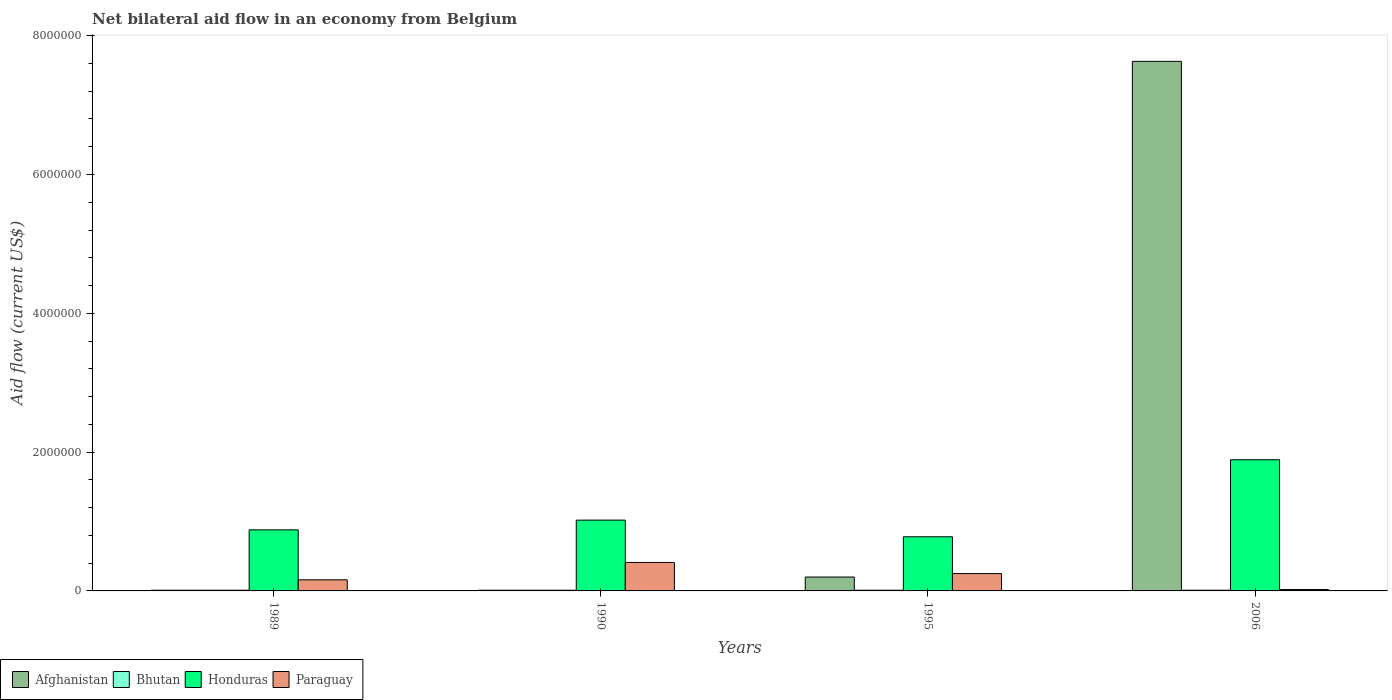How many groups of bars are there?
Provide a short and direct response. 4. Are the number of bars on each tick of the X-axis equal?
Provide a short and direct response. Yes. How many bars are there on the 1st tick from the right?
Provide a succinct answer. 4. What is the label of the 1st group of bars from the left?
Offer a very short reply. 1989. In how many cases, is the number of bars for a given year not equal to the number of legend labels?
Your answer should be compact. 0. What is the net bilateral aid flow in Honduras in 2006?
Keep it short and to the point. 1.89e+06. Across all years, what is the maximum net bilateral aid flow in Afghanistan?
Offer a very short reply. 7.63e+06. Across all years, what is the minimum net bilateral aid flow in Paraguay?
Provide a succinct answer. 2.00e+04. In which year was the net bilateral aid flow in Afghanistan maximum?
Offer a very short reply. 2006. In which year was the net bilateral aid flow in Honduras minimum?
Provide a succinct answer. 1995. What is the total net bilateral aid flow in Bhutan in the graph?
Make the answer very short. 4.00e+04. In the year 1995, what is the difference between the net bilateral aid flow in Paraguay and net bilateral aid flow in Afghanistan?
Provide a short and direct response. 5.00e+04. In how many years, is the net bilateral aid flow in Paraguay greater than 4400000 US$?
Ensure brevity in your answer.  0. What is the ratio of the net bilateral aid flow in Honduras in 1995 to that in 2006?
Your response must be concise. 0.41. Is the difference between the net bilateral aid flow in Paraguay in 1989 and 2006 greater than the difference between the net bilateral aid flow in Afghanistan in 1989 and 2006?
Provide a succinct answer. Yes. What is the difference between the highest and the second highest net bilateral aid flow in Afghanistan?
Your response must be concise. 7.43e+06. Is it the case that in every year, the sum of the net bilateral aid flow in Paraguay and net bilateral aid flow in Afghanistan is greater than the sum of net bilateral aid flow in Honduras and net bilateral aid flow in Bhutan?
Your answer should be very brief. No. What does the 4th bar from the left in 2006 represents?
Your answer should be compact. Paraguay. What does the 3rd bar from the right in 1995 represents?
Offer a very short reply. Bhutan. Is it the case that in every year, the sum of the net bilateral aid flow in Bhutan and net bilateral aid flow in Paraguay is greater than the net bilateral aid flow in Honduras?
Your answer should be compact. No. How many bars are there?
Keep it short and to the point. 16. Are all the bars in the graph horizontal?
Your answer should be very brief. No. How many years are there in the graph?
Make the answer very short. 4. Does the graph contain any zero values?
Provide a succinct answer. No. Where does the legend appear in the graph?
Ensure brevity in your answer.  Bottom left. How are the legend labels stacked?
Ensure brevity in your answer.  Horizontal. What is the title of the graph?
Keep it short and to the point. Net bilateral aid flow in an economy from Belgium. What is the label or title of the Y-axis?
Provide a short and direct response. Aid flow (current US$). What is the Aid flow (current US$) of Afghanistan in 1989?
Keep it short and to the point. 10000. What is the Aid flow (current US$) in Bhutan in 1989?
Offer a terse response. 10000. What is the Aid flow (current US$) of Honduras in 1989?
Offer a very short reply. 8.80e+05. What is the Aid flow (current US$) of Paraguay in 1989?
Offer a very short reply. 1.60e+05. What is the Aid flow (current US$) of Afghanistan in 1990?
Give a very brief answer. 10000. What is the Aid flow (current US$) of Honduras in 1990?
Provide a succinct answer. 1.02e+06. What is the Aid flow (current US$) of Afghanistan in 1995?
Give a very brief answer. 2.00e+05. What is the Aid flow (current US$) in Bhutan in 1995?
Your response must be concise. 10000. What is the Aid flow (current US$) in Honduras in 1995?
Your answer should be very brief. 7.80e+05. What is the Aid flow (current US$) in Paraguay in 1995?
Offer a terse response. 2.50e+05. What is the Aid flow (current US$) of Afghanistan in 2006?
Your answer should be very brief. 7.63e+06. What is the Aid flow (current US$) of Bhutan in 2006?
Your response must be concise. 10000. What is the Aid flow (current US$) of Honduras in 2006?
Offer a terse response. 1.89e+06. What is the Aid flow (current US$) in Paraguay in 2006?
Your response must be concise. 2.00e+04. Across all years, what is the maximum Aid flow (current US$) in Afghanistan?
Provide a short and direct response. 7.63e+06. Across all years, what is the maximum Aid flow (current US$) of Bhutan?
Give a very brief answer. 10000. Across all years, what is the maximum Aid flow (current US$) of Honduras?
Make the answer very short. 1.89e+06. Across all years, what is the maximum Aid flow (current US$) in Paraguay?
Keep it short and to the point. 4.10e+05. Across all years, what is the minimum Aid flow (current US$) in Honduras?
Give a very brief answer. 7.80e+05. Across all years, what is the minimum Aid flow (current US$) in Paraguay?
Provide a short and direct response. 2.00e+04. What is the total Aid flow (current US$) of Afghanistan in the graph?
Make the answer very short. 7.85e+06. What is the total Aid flow (current US$) in Honduras in the graph?
Offer a terse response. 4.57e+06. What is the total Aid flow (current US$) in Paraguay in the graph?
Your response must be concise. 8.40e+05. What is the difference between the Aid flow (current US$) in Afghanistan in 1989 and that in 1990?
Provide a short and direct response. 0. What is the difference between the Aid flow (current US$) in Bhutan in 1989 and that in 1990?
Provide a succinct answer. 0. What is the difference between the Aid flow (current US$) of Paraguay in 1989 and that in 1990?
Ensure brevity in your answer.  -2.50e+05. What is the difference between the Aid flow (current US$) in Afghanistan in 1989 and that in 1995?
Your answer should be very brief. -1.90e+05. What is the difference between the Aid flow (current US$) in Bhutan in 1989 and that in 1995?
Make the answer very short. 0. What is the difference between the Aid flow (current US$) in Honduras in 1989 and that in 1995?
Your answer should be very brief. 1.00e+05. What is the difference between the Aid flow (current US$) of Paraguay in 1989 and that in 1995?
Give a very brief answer. -9.00e+04. What is the difference between the Aid flow (current US$) of Afghanistan in 1989 and that in 2006?
Provide a short and direct response. -7.62e+06. What is the difference between the Aid flow (current US$) in Bhutan in 1989 and that in 2006?
Your response must be concise. 0. What is the difference between the Aid flow (current US$) in Honduras in 1989 and that in 2006?
Your answer should be compact. -1.01e+06. What is the difference between the Aid flow (current US$) of Afghanistan in 1990 and that in 1995?
Make the answer very short. -1.90e+05. What is the difference between the Aid flow (current US$) in Honduras in 1990 and that in 1995?
Provide a succinct answer. 2.40e+05. What is the difference between the Aid flow (current US$) in Paraguay in 1990 and that in 1995?
Give a very brief answer. 1.60e+05. What is the difference between the Aid flow (current US$) in Afghanistan in 1990 and that in 2006?
Your answer should be compact. -7.62e+06. What is the difference between the Aid flow (current US$) of Bhutan in 1990 and that in 2006?
Your answer should be compact. 0. What is the difference between the Aid flow (current US$) of Honduras in 1990 and that in 2006?
Keep it short and to the point. -8.70e+05. What is the difference between the Aid flow (current US$) in Afghanistan in 1995 and that in 2006?
Provide a short and direct response. -7.43e+06. What is the difference between the Aid flow (current US$) of Bhutan in 1995 and that in 2006?
Your response must be concise. 0. What is the difference between the Aid flow (current US$) in Honduras in 1995 and that in 2006?
Your response must be concise. -1.11e+06. What is the difference between the Aid flow (current US$) in Paraguay in 1995 and that in 2006?
Your answer should be very brief. 2.30e+05. What is the difference between the Aid flow (current US$) of Afghanistan in 1989 and the Aid flow (current US$) of Bhutan in 1990?
Ensure brevity in your answer.  0. What is the difference between the Aid flow (current US$) of Afghanistan in 1989 and the Aid flow (current US$) of Honduras in 1990?
Ensure brevity in your answer.  -1.01e+06. What is the difference between the Aid flow (current US$) of Afghanistan in 1989 and the Aid flow (current US$) of Paraguay in 1990?
Offer a terse response. -4.00e+05. What is the difference between the Aid flow (current US$) of Bhutan in 1989 and the Aid flow (current US$) of Honduras in 1990?
Keep it short and to the point. -1.01e+06. What is the difference between the Aid flow (current US$) in Bhutan in 1989 and the Aid flow (current US$) in Paraguay in 1990?
Your response must be concise. -4.00e+05. What is the difference between the Aid flow (current US$) of Afghanistan in 1989 and the Aid flow (current US$) of Honduras in 1995?
Keep it short and to the point. -7.70e+05. What is the difference between the Aid flow (current US$) of Afghanistan in 1989 and the Aid flow (current US$) of Paraguay in 1995?
Provide a short and direct response. -2.40e+05. What is the difference between the Aid flow (current US$) of Bhutan in 1989 and the Aid flow (current US$) of Honduras in 1995?
Provide a short and direct response. -7.70e+05. What is the difference between the Aid flow (current US$) in Bhutan in 1989 and the Aid flow (current US$) in Paraguay in 1995?
Your answer should be very brief. -2.40e+05. What is the difference between the Aid flow (current US$) in Honduras in 1989 and the Aid flow (current US$) in Paraguay in 1995?
Provide a succinct answer. 6.30e+05. What is the difference between the Aid flow (current US$) of Afghanistan in 1989 and the Aid flow (current US$) of Honduras in 2006?
Make the answer very short. -1.88e+06. What is the difference between the Aid flow (current US$) in Bhutan in 1989 and the Aid flow (current US$) in Honduras in 2006?
Give a very brief answer. -1.88e+06. What is the difference between the Aid flow (current US$) of Bhutan in 1989 and the Aid flow (current US$) of Paraguay in 2006?
Provide a short and direct response. -10000. What is the difference between the Aid flow (current US$) of Honduras in 1989 and the Aid flow (current US$) of Paraguay in 2006?
Keep it short and to the point. 8.60e+05. What is the difference between the Aid flow (current US$) of Afghanistan in 1990 and the Aid flow (current US$) of Bhutan in 1995?
Your answer should be compact. 0. What is the difference between the Aid flow (current US$) of Afghanistan in 1990 and the Aid flow (current US$) of Honduras in 1995?
Keep it short and to the point. -7.70e+05. What is the difference between the Aid flow (current US$) in Bhutan in 1990 and the Aid flow (current US$) in Honduras in 1995?
Make the answer very short. -7.70e+05. What is the difference between the Aid flow (current US$) in Honduras in 1990 and the Aid flow (current US$) in Paraguay in 1995?
Your response must be concise. 7.70e+05. What is the difference between the Aid flow (current US$) in Afghanistan in 1990 and the Aid flow (current US$) in Bhutan in 2006?
Ensure brevity in your answer.  0. What is the difference between the Aid flow (current US$) in Afghanistan in 1990 and the Aid flow (current US$) in Honduras in 2006?
Give a very brief answer. -1.88e+06. What is the difference between the Aid flow (current US$) of Afghanistan in 1990 and the Aid flow (current US$) of Paraguay in 2006?
Ensure brevity in your answer.  -10000. What is the difference between the Aid flow (current US$) in Bhutan in 1990 and the Aid flow (current US$) in Honduras in 2006?
Provide a succinct answer. -1.88e+06. What is the difference between the Aid flow (current US$) of Afghanistan in 1995 and the Aid flow (current US$) of Honduras in 2006?
Your answer should be very brief. -1.69e+06. What is the difference between the Aid flow (current US$) of Afghanistan in 1995 and the Aid flow (current US$) of Paraguay in 2006?
Make the answer very short. 1.80e+05. What is the difference between the Aid flow (current US$) in Bhutan in 1995 and the Aid flow (current US$) in Honduras in 2006?
Your answer should be very brief. -1.88e+06. What is the difference between the Aid flow (current US$) of Honduras in 1995 and the Aid flow (current US$) of Paraguay in 2006?
Keep it short and to the point. 7.60e+05. What is the average Aid flow (current US$) in Afghanistan per year?
Make the answer very short. 1.96e+06. What is the average Aid flow (current US$) in Honduras per year?
Your answer should be very brief. 1.14e+06. In the year 1989, what is the difference between the Aid flow (current US$) of Afghanistan and Aid flow (current US$) of Bhutan?
Offer a terse response. 0. In the year 1989, what is the difference between the Aid flow (current US$) of Afghanistan and Aid flow (current US$) of Honduras?
Offer a terse response. -8.70e+05. In the year 1989, what is the difference between the Aid flow (current US$) of Bhutan and Aid flow (current US$) of Honduras?
Provide a short and direct response. -8.70e+05. In the year 1989, what is the difference between the Aid flow (current US$) of Bhutan and Aid flow (current US$) of Paraguay?
Offer a very short reply. -1.50e+05. In the year 1989, what is the difference between the Aid flow (current US$) in Honduras and Aid flow (current US$) in Paraguay?
Offer a very short reply. 7.20e+05. In the year 1990, what is the difference between the Aid flow (current US$) of Afghanistan and Aid flow (current US$) of Bhutan?
Your answer should be compact. 0. In the year 1990, what is the difference between the Aid flow (current US$) in Afghanistan and Aid flow (current US$) in Honduras?
Make the answer very short. -1.01e+06. In the year 1990, what is the difference between the Aid flow (current US$) in Afghanistan and Aid flow (current US$) in Paraguay?
Provide a succinct answer. -4.00e+05. In the year 1990, what is the difference between the Aid flow (current US$) of Bhutan and Aid flow (current US$) of Honduras?
Your response must be concise. -1.01e+06. In the year 1990, what is the difference between the Aid flow (current US$) in Bhutan and Aid flow (current US$) in Paraguay?
Your answer should be compact. -4.00e+05. In the year 1995, what is the difference between the Aid flow (current US$) in Afghanistan and Aid flow (current US$) in Bhutan?
Your answer should be very brief. 1.90e+05. In the year 1995, what is the difference between the Aid flow (current US$) of Afghanistan and Aid flow (current US$) of Honduras?
Offer a very short reply. -5.80e+05. In the year 1995, what is the difference between the Aid flow (current US$) of Afghanistan and Aid flow (current US$) of Paraguay?
Make the answer very short. -5.00e+04. In the year 1995, what is the difference between the Aid flow (current US$) of Bhutan and Aid flow (current US$) of Honduras?
Offer a very short reply. -7.70e+05. In the year 1995, what is the difference between the Aid flow (current US$) of Bhutan and Aid flow (current US$) of Paraguay?
Your response must be concise. -2.40e+05. In the year 1995, what is the difference between the Aid flow (current US$) of Honduras and Aid flow (current US$) of Paraguay?
Your answer should be very brief. 5.30e+05. In the year 2006, what is the difference between the Aid flow (current US$) of Afghanistan and Aid flow (current US$) of Bhutan?
Offer a terse response. 7.62e+06. In the year 2006, what is the difference between the Aid flow (current US$) in Afghanistan and Aid flow (current US$) in Honduras?
Offer a very short reply. 5.74e+06. In the year 2006, what is the difference between the Aid flow (current US$) in Afghanistan and Aid flow (current US$) in Paraguay?
Offer a terse response. 7.61e+06. In the year 2006, what is the difference between the Aid flow (current US$) of Bhutan and Aid flow (current US$) of Honduras?
Give a very brief answer. -1.88e+06. In the year 2006, what is the difference between the Aid flow (current US$) of Bhutan and Aid flow (current US$) of Paraguay?
Provide a short and direct response. -10000. In the year 2006, what is the difference between the Aid flow (current US$) of Honduras and Aid flow (current US$) of Paraguay?
Keep it short and to the point. 1.87e+06. What is the ratio of the Aid flow (current US$) of Afghanistan in 1989 to that in 1990?
Provide a short and direct response. 1. What is the ratio of the Aid flow (current US$) of Bhutan in 1989 to that in 1990?
Your answer should be very brief. 1. What is the ratio of the Aid flow (current US$) of Honduras in 1989 to that in 1990?
Provide a short and direct response. 0.86. What is the ratio of the Aid flow (current US$) of Paraguay in 1989 to that in 1990?
Your answer should be very brief. 0.39. What is the ratio of the Aid flow (current US$) of Afghanistan in 1989 to that in 1995?
Offer a very short reply. 0.05. What is the ratio of the Aid flow (current US$) of Honduras in 1989 to that in 1995?
Your response must be concise. 1.13. What is the ratio of the Aid flow (current US$) of Paraguay in 1989 to that in 1995?
Keep it short and to the point. 0.64. What is the ratio of the Aid flow (current US$) in Afghanistan in 1989 to that in 2006?
Keep it short and to the point. 0. What is the ratio of the Aid flow (current US$) in Honduras in 1989 to that in 2006?
Offer a very short reply. 0.47. What is the ratio of the Aid flow (current US$) of Afghanistan in 1990 to that in 1995?
Keep it short and to the point. 0.05. What is the ratio of the Aid flow (current US$) in Bhutan in 1990 to that in 1995?
Your answer should be compact. 1. What is the ratio of the Aid flow (current US$) of Honduras in 1990 to that in 1995?
Offer a very short reply. 1.31. What is the ratio of the Aid flow (current US$) of Paraguay in 1990 to that in 1995?
Offer a very short reply. 1.64. What is the ratio of the Aid flow (current US$) of Afghanistan in 1990 to that in 2006?
Ensure brevity in your answer.  0. What is the ratio of the Aid flow (current US$) in Bhutan in 1990 to that in 2006?
Offer a very short reply. 1. What is the ratio of the Aid flow (current US$) of Honduras in 1990 to that in 2006?
Give a very brief answer. 0.54. What is the ratio of the Aid flow (current US$) in Paraguay in 1990 to that in 2006?
Offer a terse response. 20.5. What is the ratio of the Aid flow (current US$) in Afghanistan in 1995 to that in 2006?
Make the answer very short. 0.03. What is the ratio of the Aid flow (current US$) in Bhutan in 1995 to that in 2006?
Your response must be concise. 1. What is the ratio of the Aid flow (current US$) in Honduras in 1995 to that in 2006?
Your response must be concise. 0.41. What is the ratio of the Aid flow (current US$) of Paraguay in 1995 to that in 2006?
Your response must be concise. 12.5. What is the difference between the highest and the second highest Aid flow (current US$) in Afghanistan?
Ensure brevity in your answer.  7.43e+06. What is the difference between the highest and the second highest Aid flow (current US$) in Bhutan?
Your response must be concise. 0. What is the difference between the highest and the second highest Aid flow (current US$) of Honduras?
Provide a succinct answer. 8.70e+05. What is the difference between the highest and the lowest Aid flow (current US$) in Afghanistan?
Make the answer very short. 7.62e+06. What is the difference between the highest and the lowest Aid flow (current US$) in Bhutan?
Your response must be concise. 0. What is the difference between the highest and the lowest Aid flow (current US$) in Honduras?
Offer a very short reply. 1.11e+06. What is the difference between the highest and the lowest Aid flow (current US$) in Paraguay?
Keep it short and to the point. 3.90e+05. 